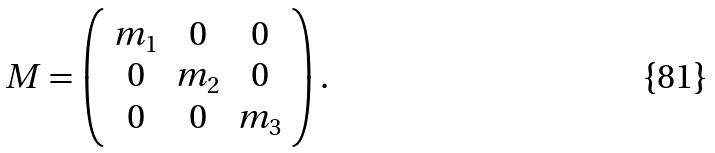<formula> <loc_0><loc_0><loc_500><loc_500>M = \left ( \begin{array} { c c c } m _ { 1 } & 0 & 0 \\ 0 & m _ { 2 } & 0 \\ 0 & 0 & m _ { 3 } \end{array} \right ) .</formula> 